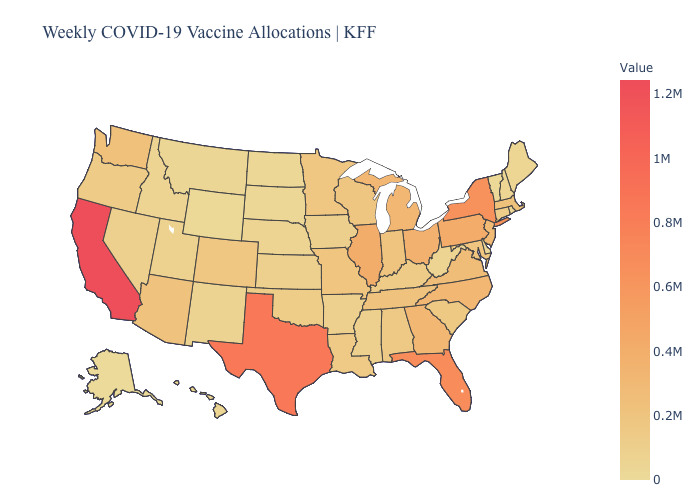Does Delaware have the lowest value in the South?
Answer briefly. Yes. Does Illinois have the highest value in the MidWest?
Short answer required. Yes. Which states have the highest value in the USA?
Concise answer only. California. Which states hav the highest value in the MidWest?
Keep it brief. Illinois. Among the states that border Rhode Island , does Connecticut have the lowest value?
Keep it brief. Yes. Among the states that border Delaware , does New Jersey have the lowest value?
Quick response, please. No. Does Pennsylvania have a lower value than New York?
Give a very brief answer. Yes. Which states have the lowest value in the MidWest?
Short answer required. North Dakota. Among the states that border South Dakota , does Iowa have the highest value?
Keep it brief. No. 